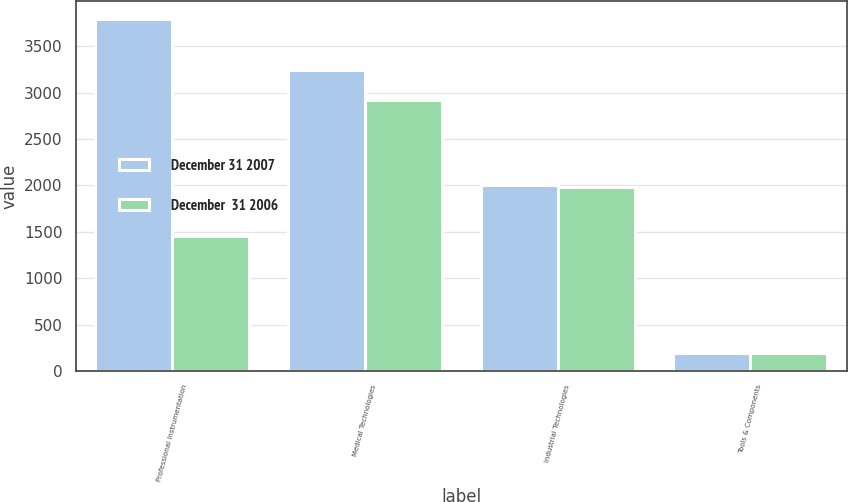Convert chart to OTSL. <chart><loc_0><loc_0><loc_500><loc_500><stacked_bar_chart><ecel><fcel>Professional Instrumentation<fcel>Medical Technologies<fcel>Industrial Technologies<fcel>Tools & Components<nl><fcel>December 31 2007<fcel>3797<fcel>3244<fcel>2006<fcel>194<nl><fcel>December  31 2006<fcel>1455<fcel>2924<fcel>1987<fcel>194<nl></chart> 